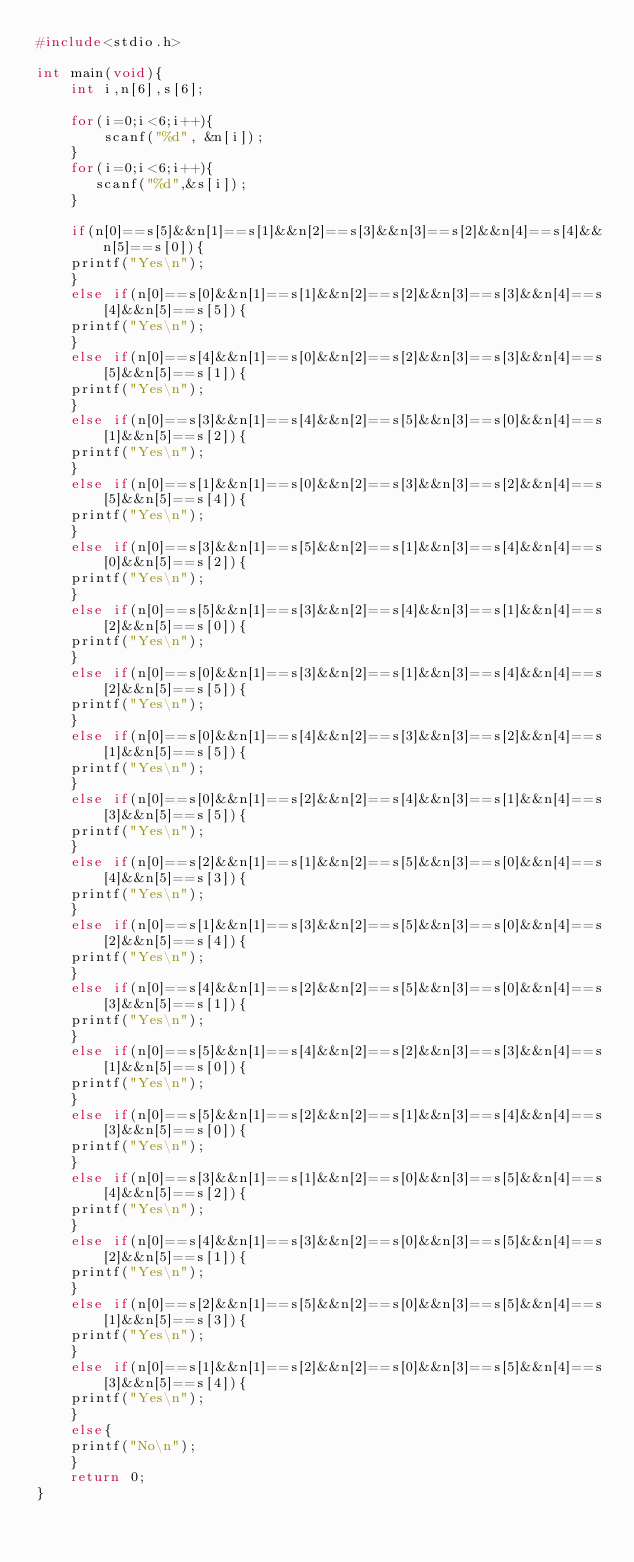Convert code to text. <code><loc_0><loc_0><loc_500><loc_500><_C_>#include<stdio.h>
 
int main(void){
    int i,n[6],s[6];
     
    for(i=0;i<6;i++){
        scanf("%d", &n[i]);
    }
    for(i=0;i<6;i++){
       scanf("%d",&s[i]);
    }
     
    if(n[0]==s[5]&&n[1]==s[1]&&n[2]==s[3]&&n[3]==s[2]&&n[4]==s[4]&&n[5]==s[0]){
    printf("Yes\n");
    }
    else if(n[0]==s[0]&&n[1]==s[1]&&n[2]==s[2]&&n[3]==s[3]&&n[4]==s[4]&&n[5]==s[5]){
    printf("Yes\n");
    }
    else if(n[0]==s[4]&&n[1]==s[0]&&n[2]==s[2]&&n[3]==s[3]&&n[4]==s[5]&&n[5]==s[1]){
    printf("Yes\n");
    }
    else if(n[0]==s[3]&&n[1]==s[4]&&n[2]==s[5]&&n[3]==s[0]&&n[4]==s[1]&&n[5]==s[2]){
    printf("Yes\n");
    }
    else if(n[0]==s[1]&&n[1]==s[0]&&n[2]==s[3]&&n[3]==s[2]&&n[4]==s[5]&&n[5]==s[4]){
    printf("Yes\n");
    }
    else if(n[0]==s[3]&&n[1]==s[5]&&n[2]==s[1]&&n[3]==s[4]&&n[4]==s[0]&&n[5]==s[2]){
    printf("Yes\n");
    }
    else if(n[0]==s[5]&&n[1]==s[3]&&n[2]==s[4]&&n[3]==s[1]&&n[4]==s[2]&&n[5]==s[0]){
    printf("Yes\n");
    }
    else if(n[0]==s[0]&&n[1]==s[3]&&n[2]==s[1]&&n[3]==s[4]&&n[4]==s[2]&&n[5]==s[5]){
    printf("Yes\n");
    }
    else if(n[0]==s[0]&&n[1]==s[4]&&n[2]==s[3]&&n[3]==s[2]&&n[4]==s[1]&&n[5]==s[5]){
    printf("Yes\n");
    }
    else if(n[0]==s[0]&&n[1]==s[2]&&n[2]==s[4]&&n[3]==s[1]&&n[4]==s[3]&&n[5]==s[5]){
    printf("Yes\n");
    }
    else if(n[0]==s[2]&&n[1]==s[1]&&n[2]==s[5]&&n[3]==s[0]&&n[4]==s[4]&&n[5]==s[3]){
    printf("Yes\n");
    }
    else if(n[0]==s[1]&&n[1]==s[3]&&n[2]==s[5]&&n[3]==s[0]&&n[4]==s[2]&&n[5]==s[4]){
    printf("Yes\n");
    }
    else if(n[0]==s[4]&&n[1]==s[2]&&n[2]==s[5]&&n[3]==s[0]&&n[4]==s[3]&&n[5]==s[1]){
    printf("Yes\n");
    }
    else if(n[0]==s[5]&&n[1]==s[4]&&n[2]==s[2]&&n[3]==s[3]&&n[4]==s[1]&&n[5]==s[0]){
    printf("Yes\n");
    }
    else if(n[0]==s[5]&&n[1]==s[2]&&n[2]==s[1]&&n[3]==s[4]&&n[4]==s[3]&&n[5]==s[0]){
    printf("Yes\n");
    }
    else if(n[0]==s[3]&&n[1]==s[1]&&n[2]==s[0]&&n[3]==s[5]&&n[4]==s[4]&&n[5]==s[2]){
    printf("Yes\n");
    }
    else if(n[0]==s[4]&&n[1]==s[3]&&n[2]==s[0]&&n[3]==s[5]&&n[4]==s[2]&&n[5]==s[1]){
    printf("Yes\n");
    }
    else if(n[0]==s[2]&&n[1]==s[5]&&n[2]==s[0]&&n[3]==s[5]&&n[4]==s[1]&&n[5]==s[3]){
    printf("Yes\n");
    }
    else if(n[0]==s[1]&&n[1]==s[2]&&n[2]==s[0]&&n[3]==s[5]&&n[4]==s[3]&&n[5]==s[4]){
    printf("Yes\n");
    }
    else{
    printf("No\n");
    }
    return 0;
}

</code> 